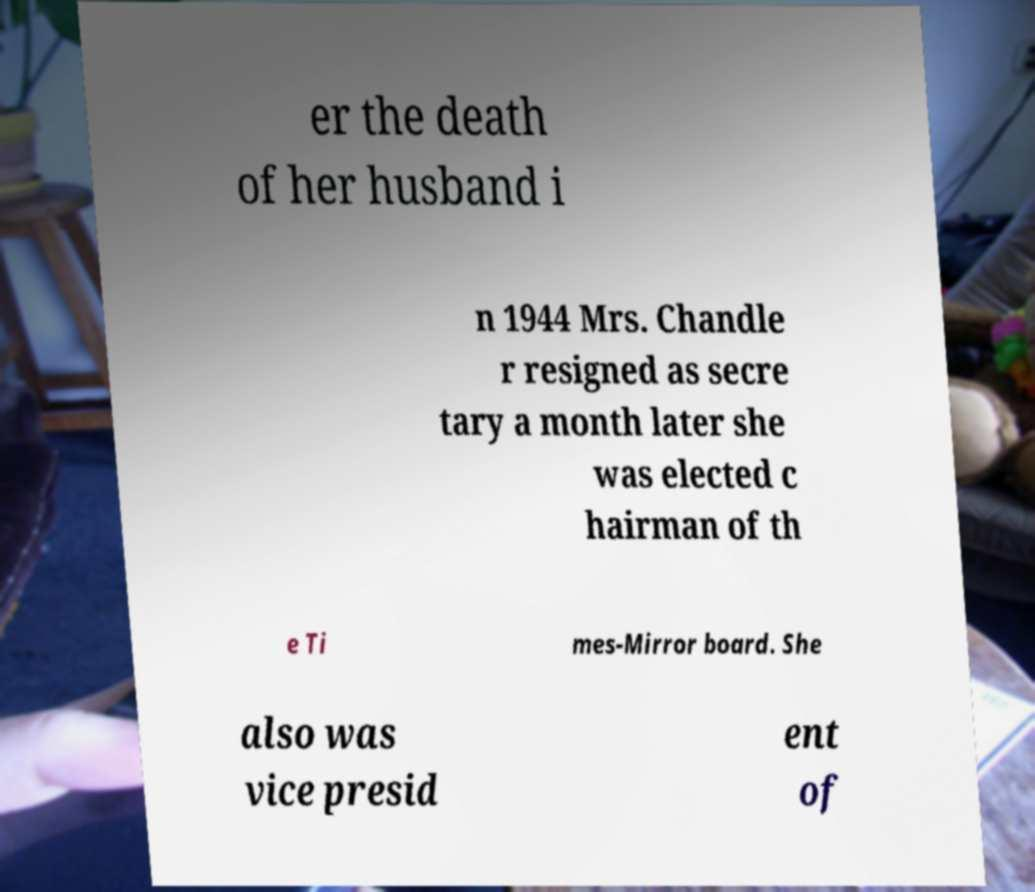Can you read and provide the text displayed in the image?This photo seems to have some interesting text. Can you extract and type it out for me? er the death of her husband i n 1944 Mrs. Chandle r resigned as secre tary a month later she was elected c hairman of th e Ti mes-Mirror board. She also was vice presid ent of 